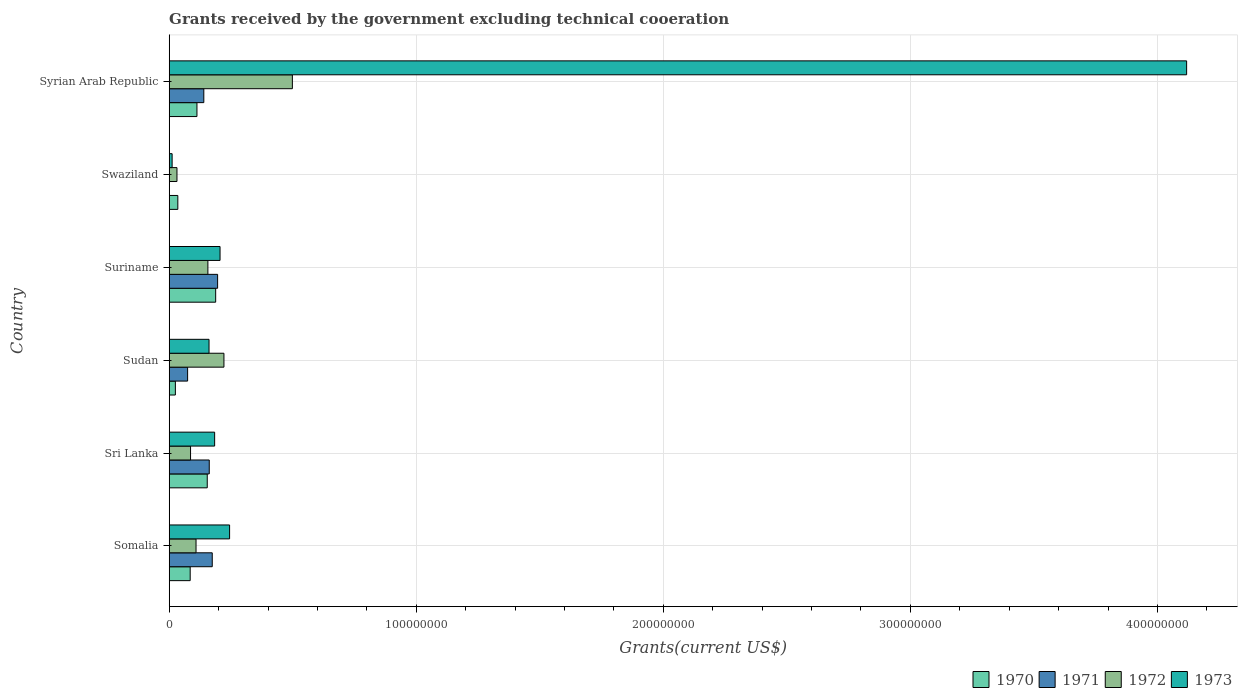How many bars are there on the 1st tick from the top?
Provide a succinct answer. 4. What is the label of the 3rd group of bars from the top?
Your answer should be very brief. Suriname. What is the total grants received by the government in 1970 in Sri Lanka?
Give a very brief answer. 1.54e+07. Across all countries, what is the maximum total grants received by the government in 1973?
Give a very brief answer. 4.12e+08. Across all countries, what is the minimum total grants received by the government in 1973?
Your response must be concise. 1.18e+06. In which country was the total grants received by the government in 1973 maximum?
Your response must be concise. Syrian Arab Republic. What is the total total grants received by the government in 1971 in the graph?
Offer a terse response. 7.47e+07. What is the difference between the total grants received by the government in 1972 in Sri Lanka and that in Sudan?
Your answer should be compact. -1.35e+07. What is the difference between the total grants received by the government in 1973 in Syrian Arab Republic and the total grants received by the government in 1970 in Swaziland?
Make the answer very short. 4.08e+08. What is the average total grants received by the government in 1971 per country?
Offer a terse response. 1.24e+07. What is the difference between the total grants received by the government in 1970 and total grants received by the government in 1971 in Somalia?
Provide a succinct answer. -8.93e+06. What is the ratio of the total grants received by the government in 1970 in Sudan to that in Syrian Arab Republic?
Provide a succinct answer. 0.22. Is the total grants received by the government in 1973 in Suriname less than that in Swaziland?
Offer a very short reply. No. Is the difference between the total grants received by the government in 1970 in Sudan and Suriname greater than the difference between the total grants received by the government in 1971 in Sudan and Suriname?
Your answer should be compact. No. What is the difference between the highest and the second highest total grants received by the government in 1972?
Give a very brief answer. 2.77e+07. What is the difference between the highest and the lowest total grants received by the government in 1970?
Offer a very short reply. 1.63e+07. Does the graph contain grids?
Offer a terse response. Yes. What is the title of the graph?
Provide a short and direct response. Grants received by the government excluding technical cooeration. Does "1987" appear as one of the legend labels in the graph?
Your response must be concise. No. What is the label or title of the X-axis?
Your answer should be very brief. Grants(current US$). What is the Grants(current US$) in 1970 in Somalia?
Keep it short and to the point. 8.49e+06. What is the Grants(current US$) in 1971 in Somalia?
Give a very brief answer. 1.74e+07. What is the Grants(current US$) in 1972 in Somalia?
Ensure brevity in your answer.  1.09e+07. What is the Grants(current US$) in 1973 in Somalia?
Ensure brevity in your answer.  2.44e+07. What is the Grants(current US$) in 1970 in Sri Lanka?
Give a very brief answer. 1.54e+07. What is the Grants(current US$) in 1971 in Sri Lanka?
Your response must be concise. 1.62e+07. What is the Grants(current US$) of 1972 in Sri Lanka?
Your answer should be very brief. 8.64e+06. What is the Grants(current US$) of 1973 in Sri Lanka?
Offer a terse response. 1.84e+07. What is the Grants(current US$) of 1970 in Sudan?
Offer a very short reply. 2.50e+06. What is the Grants(current US$) in 1971 in Sudan?
Your response must be concise. 7.45e+06. What is the Grants(current US$) in 1972 in Sudan?
Provide a succinct answer. 2.22e+07. What is the Grants(current US$) of 1973 in Sudan?
Your answer should be very brief. 1.61e+07. What is the Grants(current US$) in 1970 in Suriname?
Provide a succinct answer. 1.88e+07. What is the Grants(current US$) in 1971 in Suriname?
Your answer should be compact. 1.96e+07. What is the Grants(current US$) of 1972 in Suriname?
Your answer should be very brief. 1.57e+07. What is the Grants(current US$) in 1973 in Suriname?
Provide a short and direct response. 2.06e+07. What is the Grants(current US$) of 1970 in Swaziland?
Offer a very short reply. 3.49e+06. What is the Grants(current US$) of 1971 in Swaziland?
Offer a very short reply. 0. What is the Grants(current US$) of 1972 in Swaziland?
Give a very brief answer. 3.14e+06. What is the Grants(current US$) of 1973 in Swaziland?
Offer a terse response. 1.18e+06. What is the Grants(current US$) of 1970 in Syrian Arab Republic?
Your answer should be very brief. 1.12e+07. What is the Grants(current US$) in 1971 in Syrian Arab Republic?
Provide a short and direct response. 1.40e+07. What is the Grants(current US$) of 1972 in Syrian Arab Republic?
Keep it short and to the point. 4.98e+07. What is the Grants(current US$) of 1973 in Syrian Arab Republic?
Ensure brevity in your answer.  4.12e+08. Across all countries, what is the maximum Grants(current US$) in 1970?
Offer a very short reply. 1.88e+07. Across all countries, what is the maximum Grants(current US$) in 1971?
Offer a very short reply. 1.96e+07. Across all countries, what is the maximum Grants(current US$) of 1972?
Ensure brevity in your answer.  4.98e+07. Across all countries, what is the maximum Grants(current US$) in 1973?
Ensure brevity in your answer.  4.12e+08. Across all countries, what is the minimum Grants(current US$) of 1970?
Provide a short and direct response. 2.50e+06. Across all countries, what is the minimum Grants(current US$) in 1972?
Provide a succinct answer. 3.14e+06. Across all countries, what is the minimum Grants(current US$) in 1973?
Provide a succinct answer. 1.18e+06. What is the total Grants(current US$) of 1970 in the graph?
Give a very brief answer. 5.99e+07. What is the total Grants(current US$) of 1971 in the graph?
Your answer should be compact. 7.47e+07. What is the total Grants(current US$) of 1972 in the graph?
Your answer should be very brief. 1.10e+08. What is the total Grants(current US$) of 1973 in the graph?
Make the answer very short. 4.93e+08. What is the difference between the Grants(current US$) in 1970 in Somalia and that in Sri Lanka?
Keep it short and to the point. -6.91e+06. What is the difference between the Grants(current US$) of 1971 in Somalia and that in Sri Lanka?
Provide a succinct answer. 1.21e+06. What is the difference between the Grants(current US$) in 1972 in Somalia and that in Sri Lanka?
Ensure brevity in your answer.  2.22e+06. What is the difference between the Grants(current US$) in 1973 in Somalia and that in Sri Lanka?
Ensure brevity in your answer.  6.05e+06. What is the difference between the Grants(current US$) of 1970 in Somalia and that in Sudan?
Offer a very short reply. 5.99e+06. What is the difference between the Grants(current US$) of 1971 in Somalia and that in Sudan?
Keep it short and to the point. 9.97e+06. What is the difference between the Grants(current US$) of 1972 in Somalia and that in Sudan?
Give a very brief answer. -1.13e+07. What is the difference between the Grants(current US$) of 1973 in Somalia and that in Sudan?
Offer a terse response. 8.32e+06. What is the difference between the Grants(current US$) in 1970 in Somalia and that in Suriname?
Make the answer very short. -1.03e+07. What is the difference between the Grants(current US$) in 1971 in Somalia and that in Suriname?
Provide a succinct answer. -2.17e+06. What is the difference between the Grants(current US$) of 1972 in Somalia and that in Suriname?
Your response must be concise. -4.80e+06. What is the difference between the Grants(current US$) in 1973 in Somalia and that in Suriname?
Make the answer very short. 3.86e+06. What is the difference between the Grants(current US$) of 1972 in Somalia and that in Swaziland?
Offer a terse response. 7.72e+06. What is the difference between the Grants(current US$) of 1973 in Somalia and that in Swaziland?
Offer a very short reply. 2.33e+07. What is the difference between the Grants(current US$) in 1970 in Somalia and that in Syrian Arab Republic?
Your answer should be compact. -2.74e+06. What is the difference between the Grants(current US$) of 1971 in Somalia and that in Syrian Arab Republic?
Your answer should be very brief. 3.41e+06. What is the difference between the Grants(current US$) in 1972 in Somalia and that in Syrian Arab Republic?
Keep it short and to the point. -3.90e+07. What is the difference between the Grants(current US$) of 1973 in Somalia and that in Syrian Arab Republic?
Provide a succinct answer. -3.87e+08. What is the difference between the Grants(current US$) of 1970 in Sri Lanka and that in Sudan?
Your answer should be very brief. 1.29e+07. What is the difference between the Grants(current US$) of 1971 in Sri Lanka and that in Sudan?
Provide a short and direct response. 8.76e+06. What is the difference between the Grants(current US$) of 1972 in Sri Lanka and that in Sudan?
Your response must be concise. -1.35e+07. What is the difference between the Grants(current US$) in 1973 in Sri Lanka and that in Sudan?
Offer a terse response. 2.27e+06. What is the difference between the Grants(current US$) of 1970 in Sri Lanka and that in Suriname?
Ensure brevity in your answer.  -3.41e+06. What is the difference between the Grants(current US$) in 1971 in Sri Lanka and that in Suriname?
Provide a short and direct response. -3.38e+06. What is the difference between the Grants(current US$) in 1972 in Sri Lanka and that in Suriname?
Your answer should be very brief. -7.02e+06. What is the difference between the Grants(current US$) of 1973 in Sri Lanka and that in Suriname?
Your answer should be very brief. -2.19e+06. What is the difference between the Grants(current US$) in 1970 in Sri Lanka and that in Swaziland?
Offer a terse response. 1.19e+07. What is the difference between the Grants(current US$) of 1972 in Sri Lanka and that in Swaziland?
Ensure brevity in your answer.  5.50e+06. What is the difference between the Grants(current US$) of 1973 in Sri Lanka and that in Swaziland?
Keep it short and to the point. 1.72e+07. What is the difference between the Grants(current US$) in 1970 in Sri Lanka and that in Syrian Arab Republic?
Keep it short and to the point. 4.17e+06. What is the difference between the Grants(current US$) in 1971 in Sri Lanka and that in Syrian Arab Republic?
Give a very brief answer. 2.20e+06. What is the difference between the Grants(current US$) of 1972 in Sri Lanka and that in Syrian Arab Republic?
Ensure brevity in your answer.  -4.12e+07. What is the difference between the Grants(current US$) in 1973 in Sri Lanka and that in Syrian Arab Republic?
Ensure brevity in your answer.  -3.93e+08. What is the difference between the Grants(current US$) in 1970 in Sudan and that in Suriname?
Offer a terse response. -1.63e+07. What is the difference between the Grants(current US$) of 1971 in Sudan and that in Suriname?
Ensure brevity in your answer.  -1.21e+07. What is the difference between the Grants(current US$) of 1972 in Sudan and that in Suriname?
Your answer should be compact. 6.49e+06. What is the difference between the Grants(current US$) of 1973 in Sudan and that in Suriname?
Offer a very short reply. -4.46e+06. What is the difference between the Grants(current US$) of 1970 in Sudan and that in Swaziland?
Keep it short and to the point. -9.90e+05. What is the difference between the Grants(current US$) of 1972 in Sudan and that in Swaziland?
Ensure brevity in your answer.  1.90e+07. What is the difference between the Grants(current US$) in 1973 in Sudan and that in Swaziland?
Give a very brief answer. 1.49e+07. What is the difference between the Grants(current US$) of 1970 in Sudan and that in Syrian Arab Republic?
Provide a succinct answer. -8.73e+06. What is the difference between the Grants(current US$) in 1971 in Sudan and that in Syrian Arab Republic?
Your answer should be compact. -6.56e+06. What is the difference between the Grants(current US$) in 1972 in Sudan and that in Syrian Arab Republic?
Your answer should be compact. -2.77e+07. What is the difference between the Grants(current US$) in 1973 in Sudan and that in Syrian Arab Republic?
Provide a succinct answer. -3.96e+08. What is the difference between the Grants(current US$) of 1970 in Suriname and that in Swaziland?
Keep it short and to the point. 1.53e+07. What is the difference between the Grants(current US$) of 1972 in Suriname and that in Swaziland?
Keep it short and to the point. 1.25e+07. What is the difference between the Grants(current US$) of 1973 in Suriname and that in Swaziland?
Offer a very short reply. 1.94e+07. What is the difference between the Grants(current US$) in 1970 in Suriname and that in Syrian Arab Republic?
Provide a short and direct response. 7.58e+06. What is the difference between the Grants(current US$) of 1971 in Suriname and that in Syrian Arab Republic?
Offer a terse response. 5.58e+06. What is the difference between the Grants(current US$) in 1972 in Suriname and that in Syrian Arab Republic?
Your answer should be compact. -3.42e+07. What is the difference between the Grants(current US$) in 1973 in Suriname and that in Syrian Arab Republic?
Your response must be concise. -3.91e+08. What is the difference between the Grants(current US$) in 1970 in Swaziland and that in Syrian Arab Republic?
Your response must be concise. -7.74e+06. What is the difference between the Grants(current US$) in 1972 in Swaziland and that in Syrian Arab Republic?
Offer a very short reply. -4.67e+07. What is the difference between the Grants(current US$) of 1973 in Swaziland and that in Syrian Arab Republic?
Provide a succinct answer. -4.11e+08. What is the difference between the Grants(current US$) in 1970 in Somalia and the Grants(current US$) in 1971 in Sri Lanka?
Provide a succinct answer. -7.72e+06. What is the difference between the Grants(current US$) in 1970 in Somalia and the Grants(current US$) in 1973 in Sri Lanka?
Make the answer very short. -9.90e+06. What is the difference between the Grants(current US$) in 1971 in Somalia and the Grants(current US$) in 1972 in Sri Lanka?
Your response must be concise. 8.78e+06. What is the difference between the Grants(current US$) in 1971 in Somalia and the Grants(current US$) in 1973 in Sri Lanka?
Your answer should be very brief. -9.70e+05. What is the difference between the Grants(current US$) in 1972 in Somalia and the Grants(current US$) in 1973 in Sri Lanka?
Offer a terse response. -7.53e+06. What is the difference between the Grants(current US$) in 1970 in Somalia and the Grants(current US$) in 1971 in Sudan?
Offer a very short reply. 1.04e+06. What is the difference between the Grants(current US$) of 1970 in Somalia and the Grants(current US$) of 1972 in Sudan?
Your response must be concise. -1.37e+07. What is the difference between the Grants(current US$) in 1970 in Somalia and the Grants(current US$) in 1973 in Sudan?
Keep it short and to the point. -7.63e+06. What is the difference between the Grants(current US$) in 1971 in Somalia and the Grants(current US$) in 1972 in Sudan?
Offer a very short reply. -4.73e+06. What is the difference between the Grants(current US$) of 1971 in Somalia and the Grants(current US$) of 1973 in Sudan?
Offer a very short reply. 1.30e+06. What is the difference between the Grants(current US$) of 1972 in Somalia and the Grants(current US$) of 1973 in Sudan?
Your answer should be compact. -5.26e+06. What is the difference between the Grants(current US$) in 1970 in Somalia and the Grants(current US$) in 1971 in Suriname?
Offer a terse response. -1.11e+07. What is the difference between the Grants(current US$) of 1970 in Somalia and the Grants(current US$) of 1972 in Suriname?
Give a very brief answer. -7.17e+06. What is the difference between the Grants(current US$) in 1970 in Somalia and the Grants(current US$) in 1973 in Suriname?
Offer a terse response. -1.21e+07. What is the difference between the Grants(current US$) of 1971 in Somalia and the Grants(current US$) of 1972 in Suriname?
Make the answer very short. 1.76e+06. What is the difference between the Grants(current US$) of 1971 in Somalia and the Grants(current US$) of 1973 in Suriname?
Make the answer very short. -3.16e+06. What is the difference between the Grants(current US$) of 1972 in Somalia and the Grants(current US$) of 1973 in Suriname?
Your answer should be compact. -9.72e+06. What is the difference between the Grants(current US$) of 1970 in Somalia and the Grants(current US$) of 1972 in Swaziland?
Your answer should be compact. 5.35e+06. What is the difference between the Grants(current US$) of 1970 in Somalia and the Grants(current US$) of 1973 in Swaziland?
Provide a short and direct response. 7.31e+06. What is the difference between the Grants(current US$) in 1971 in Somalia and the Grants(current US$) in 1972 in Swaziland?
Give a very brief answer. 1.43e+07. What is the difference between the Grants(current US$) in 1971 in Somalia and the Grants(current US$) in 1973 in Swaziland?
Give a very brief answer. 1.62e+07. What is the difference between the Grants(current US$) in 1972 in Somalia and the Grants(current US$) in 1973 in Swaziland?
Offer a very short reply. 9.68e+06. What is the difference between the Grants(current US$) in 1970 in Somalia and the Grants(current US$) in 1971 in Syrian Arab Republic?
Make the answer very short. -5.52e+06. What is the difference between the Grants(current US$) in 1970 in Somalia and the Grants(current US$) in 1972 in Syrian Arab Republic?
Your response must be concise. -4.14e+07. What is the difference between the Grants(current US$) in 1970 in Somalia and the Grants(current US$) in 1973 in Syrian Arab Republic?
Provide a succinct answer. -4.03e+08. What is the difference between the Grants(current US$) in 1971 in Somalia and the Grants(current US$) in 1972 in Syrian Arab Republic?
Ensure brevity in your answer.  -3.24e+07. What is the difference between the Grants(current US$) in 1971 in Somalia and the Grants(current US$) in 1973 in Syrian Arab Republic?
Your answer should be compact. -3.94e+08. What is the difference between the Grants(current US$) of 1972 in Somalia and the Grants(current US$) of 1973 in Syrian Arab Republic?
Offer a terse response. -4.01e+08. What is the difference between the Grants(current US$) in 1970 in Sri Lanka and the Grants(current US$) in 1971 in Sudan?
Ensure brevity in your answer.  7.95e+06. What is the difference between the Grants(current US$) of 1970 in Sri Lanka and the Grants(current US$) of 1972 in Sudan?
Your response must be concise. -6.75e+06. What is the difference between the Grants(current US$) of 1970 in Sri Lanka and the Grants(current US$) of 1973 in Sudan?
Offer a terse response. -7.20e+05. What is the difference between the Grants(current US$) of 1971 in Sri Lanka and the Grants(current US$) of 1972 in Sudan?
Give a very brief answer. -5.94e+06. What is the difference between the Grants(current US$) of 1972 in Sri Lanka and the Grants(current US$) of 1973 in Sudan?
Make the answer very short. -7.48e+06. What is the difference between the Grants(current US$) of 1970 in Sri Lanka and the Grants(current US$) of 1971 in Suriname?
Make the answer very short. -4.19e+06. What is the difference between the Grants(current US$) of 1970 in Sri Lanka and the Grants(current US$) of 1973 in Suriname?
Your answer should be compact. -5.18e+06. What is the difference between the Grants(current US$) in 1971 in Sri Lanka and the Grants(current US$) in 1973 in Suriname?
Your answer should be very brief. -4.37e+06. What is the difference between the Grants(current US$) of 1972 in Sri Lanka and the Grants(current US$) of 1973 in Suriname?
Make the answer very short. -1.19e+07. What is the difference between the Grants(current US$) in 1970 in Sri Lanka and the Grants(current US$) in 1972 in Swaziland?
Ensure brevity in your answer.  1.23e+07. What is the difference between the Grants(current US$) in 1970 in Sri Lanka and the Grants(current US$) in 1973 in Swaziland?
Provide a short and direct response. 1.42e+07. What is the difference between the Grants(current US$) in 1971 in Sri Lanka and the Grants(current US$) in 1972 in Swaziland?
Your answer should be compact. 1.31e+07. What is the difference between the Grants(current US$) in 1971 in Sri Lanka and the Grants(current US$) in 1973 in Swaziland?
Your answer should be compact. 1.50e+07. What is the difference between the Grants(current US$) of 1972 in Sri Lanka and the Grants(current US$) of 1973 in Swaziland?
Give a very brief answer. 7.46e+06. What is the difference between the Grants(current US$) of 1970 in Sri Lanka and the Grants(current US$) of 1971 in Syrian Arab Republic?
Provide a succinct answer. 1.39e+06. What is the difference between the Grants(current US$) in 1970 in Sri Lanka and the Grants(current US$) in 1972 in Syrian Arab Republic?
Make the answer very short. -3.44e+07. What is the difference between the Grants(current US$) in 1970 in Sri Lanka and the Grants(current US$) in 1973 in Syrian Arab Republic?
Keep it short and to the point. -3.96e+08. What is the difference between the Grants(current US$) in 1971 in Sri Lanka and the Grants(current US$) in 1972 in Syrian Arab Republic?
Provide a short and direct response. -3.36e+07. What is the difference between the Grants(current US$) of 1971 in Sri Lanka and the Grants(current US$) of 1973 in Syrian Arab Republic?
Offer a very short reply. -3.96e+08. What is the difference between the Grants(current US$) of 1972 in Sri Lanka and the Grants(current US$) of 1973 in Syrian Arab Republic?
Keep it short and to the point. -4.03e+08. What is the difference between the Grants(current US$) of 1970 in Sudan and the Grants(current US$) of 1971 in Suriname?
Give a very brief answer. -1.71e+07. What is the difference between the Grants(current US$) of 1970 in Sudan and the Grants(current US$) of 1972 in Suriname?
Your answer should be very brief. -1.32e+07. What is the difference between the Grants(current US$) in 1970 in Sudan and the Grants(current US$) in 1973 in Suriname?
Offer a very short reply. -1.81e+07. What is the difference between the Grants(current US$) in 1971 in Sudan and the Grants(current US$) in 1972 in Suriname?
Ensure brevity in your answer.  -8.21e+06. What is the difference between the Grants(current US$) in 1971 in Sudan and the Grants(current US$) in 1973 in Suriname?
Provide a short and direct response. -1.31e+07. What is the difference between the Grants(current US$) of 1972 in Sudan and the Grants(current US$) of 1973 in Suriname?
Provide a succinct answer. 1.57e+06. What is the difference between the Grants(current US$) of 1970 in Sudan and the Grants(current US$) of 1972 in Swaziland?
Keep it short and to the point. -6.40e+05. What is the difference between the Grants(current US$) in 1970 in Sudan and the Grants(current US$) in 1973 in Swaziland?
Provide a short and direct response. 1.32e+06. What is the difference between the Grants(current US$) in 1971 in Sudan and the Grants(current US$) in 1972 in Swaziland?
Keep it short and to the point. 4.31e+06. What is the difference between the Grants(current US$) of 1971 in Sudan and the Grants(current US$) of 1973 in Swaziland?
Your answer should be very brief. 6.27e+06. What is the difference between the Grants(current US$) in 1972 in Sudan and the Grants(current US$) in 1973 in Swaziland?
Provide a short and direct response. 2.10e+07. What is the difference between the Grants(current US$) in 1970 in Sudan and the Grants(current US$) in 1971 in Syrian Arab Republic?
Ensure brevity in your answer.  -1.15e+07. What is the difference between the Grants(current US$) of 1970 in Sudan and the Grants(current US$) of 1972 in Syrian Arab Republic?
Provide a succinct answer. -4.74e+07. What is the difference between the Grants(current US$) of 1970 in Sudan and the Grants(current US$) of 1973 in Syrian Arab Republic?
Offer a terse response. -4.09e+08. What is the difference between the Grants(current US$) of 1971 in Sudan and the Grants(current US$) of 1972 in Syrian Arab Republic?
Keep it short and to the point. -4.24e+07. What is the difference between the Grants(current US$) of 1971 in Sudan and the Grants(current US$) of 1973 in Syrian Arab Republic?
Make the answer very short. -4.04e+08. What is the difference between the Grants(current US$) of 1972 in Sudan and the Grants(current US$) of 1973 in Syrian Arab Republic?
Provide a short and direct response. -3.90e+08. What is the difference between the Grants(current US$) of 1970 in Suriname and the Grants(current US$) of 1972 in Swaziland?
Keep it short and to the point. 1.57e+07. What is the difference between the Grants(current US$) of 1970 in Suriname and the Grants(current US$) of 1973 in Swaziland?
Make the answer very short. 1.76e+07. What is the difference between the Grants(current US$) in 1971 in Suriname and the Grants(current US$) in 1972 in Swaziland?
Keep it short and to the point. 1.64e+07. What is the difference between the Grants(current US$) in 1971 in Suriname and the Grants(current US$) in 1973 in Swaziland?
Provide a short and direct response. 1.84e+07. What is the difference between the Grants(current US$) in 1972 in Suriname and the Grants(current US$) in 1973 in Swaziland?
Make the answer very short. 1.45e+07. What is the difference between the Grants(current US$) in 1970 in Suriname and the Grants(current US$) in 1971 in Syrian Arab Republic?
Your answer should be compact. 4.80e+06. What is the difference between the Grants(current US$) in 1970 in Suriname and the Grants(current US$) in 1972 in Syrian Arab Republic?
Offer a terse response. -3.10e+07. What is the difference between the Grants(current US$) of 1970 in Suriname and the Grants(current US$) of 1973 in Syrian Arab Republic?
Your response must be concise. -3.93e+08. What is the difference between the Grants(current US$) in 1971 in Suriname and the Grants(current US$) in 1972 in Syrian Arab Republic?
Ensure brevity in your answer.  -3.03e+07. What is the difference between the Grants(current US$) in 1971 in Suriname and the Grants(current US$) in 1973 in Syrian Arab Republic?
Your answer should be very brief. -3.92e+08. What is the difference between the Grants(current US$) of 1972 in Suriname and the Grants(current US$) of 1973 in Syrian Arab Republic?
Your answer should be very brief. -3.96e+08. What is the difference between the Grants(current US$) of 1970 in Swaziland and the Grants(current US$) of 1971 in Syrian Arab Republic?
Provide a short and direct response. -1.05e+07. What is the difference between the Grants(current US$) of 1970 in Swaziland and the Grants(current US$) of 1972 in Syrian Arab Republic?
Provide a succinct answer. -4.64e+07. What is the difference between the Grants(current US$) in 1970 in Swaziland and the Grants(current US$) in 1973 in Syrian Arab Republic?
Make the answer very short. -4.08e+08. What is the difference between the Grants(current US$) in 1972 in Swaziland and the Grants(current US$) in 1973 in Syrian Arab Republic?
Ensure brevity in your answer.  -4.09e+08. What is the average Grants(current US$) in 1970 per country?
Make the answer very short. 9.99e+06. What is the average Grants(current US$) in 1971 per country?
Give a very brief answer. 1.24e+07. What is the average Grants(current US$) of 1972 per country?
Give a very brief answer. 1.84e+07. What is the average Grants(current US$) in 1973 per country?
Your answer should be compact. 8.21e+07. What is the difference between the Grants(current US$) in 1970 and Grants(current US$) in 1971 in Somalia?
Offer a very short reply. -8.93e+06. What is the difference between the Grants(current US$) of 1970 and Grants(current US$) of 1972 in Somalia?
Ensure brevity in your answer.  -2.37e+06. What is the difference between the Grants(current US$) of 1970 and Grants(current US$) of 1973 in Somalia?
Provide a short and direct response. -1.60e+07. What is the difference between the Grants(current US$) in 1971 and Grants(current US$) in 1972 in Somalia?
Make the answer very short. 6.56e+06. What is the difference between the Grants(current US$) in 1971 and Grants(current US$) in 1973 in Somalia?
Make the answer very short. -7.02e+06. What is the difference between the Grants(current US$) in 1972 and Grants(current US$) in 1973 in Somalia?
Your answer should be very brief. -1.36e+07. What is the difference between the Grants(current US$) in 1970 and Grants(current US$) in 1971 in Sri Lanka?
Your response must be concise. -8.10e+05. What is the difference between the Grants(current US$) in 1970 and Grants(current US$) in 1972 in Sri Lanka?
Ensure brevity in your answer.  6.76e+06. What is the difference between the Grants(current US$) of 1970 and Grants(current US$) of 1973 in Sri Lanka?
Give a very brief answer. -2.99e+06. What is the difference between the Grants(current US$) of 1971 and Grants(current US$) of 1972 in Sri Lanka?
Your answer should be very brief. 7.57e+06. What is the difference between the Grants(current US$) in 1971 and Grants(current US$) in 1973 in Sri Lanka?
Ensure brevity in your answer.  -2.18e+06. What is the difference between the Grants(current US$) in 1972 and Grants(current US$) in 1973 in Sri Lanka?
Provide a succinct answer. -9.75e+06. What is the difference between the Grants(current US$) in 1970 and Grants(current US$) in 1971 in Sudan?
Your answer should be compact. -4.95e+06. What is the difference between the Grants(current US$) in 1970 and Grants(current US$) in 1972 in Sudan?
Provide a short and direct response. -1.96e+07. What is the difference between the Grants(current US$) in 1970 and Grants(current US$) in 1973 in Sudan?
Provide a short and direct response. -1.36e+07. What is the difference between the Grants(current US$) of 1971 and Grants(current US$) of 1972 in Sudan?
Your answer should be compact. -1.47e+07. What is the difference between the Grants(current US$) in 1971 and Grants(current US$) in 1973 in Sudan?
Keep it short and to the point. -8.67e+06. What is the difference between the Grants(current US$) of 1972 and Grants(current US$) of 1973 in Sudan?
Your response must be concise. 6.03e+06. What is the difference between the Grants(current US$) of 1970 and Grants(current US$) of 1971 in Suriname?
Your answer should be compact. -7.80e+05. What is the difference between the Grants(current US$) in 1970 and Grants(current US$) in 1972 in Suriname?
Provide a succinct answer. 3.15e+06. What is the difference between the Grants(current US$) in 1970 and Grants(current US$) in 1973 in Suriname?
Make the answer very short. -1.77e+06. What is the difference between the Grants(current US$) of 1971 and Grants(current US$) of 1972 in Suriname?
Give a very brief answer. 3.93e+06. What is the difference between the Grants(current US$) of 1971 and Grants(current US$) of 1973 in Suriname?
Offer a very short reply. -9.90e+05. What is the difference between the Grants(current US$) of 1972 and Grants(current US$) of 1973 in Suriname?
Your answer should be compact. -4.92e+06. What is the difference between the Grants(current US$) of 1970 and Grants(current US$) of 1973 in Swaziland?
Keep it short and to the point. 2.31e+06. What is the difference between the Grants(current US$) of 1972 and Grants(current US$) of 1973 in Swaziland?
Ensure brevity in your answer.  1.96e+06. What is the difference between the Grants(current US$) of 1970 and Grants(current US$) of 1971 in Syrian Arab Republic?
Keep it short and to the point. -2.78e+06. What is the difference between the Grants(current US$) in 1970 and Grants(current US$) in 1972 in Syrian Arab Republic?
Your answer should be very brief. -3.86e+07. What is the difference between the Grants(current US$) of 1970 and Grants(current US$) of 1973 in Syrian Arab Republic?
Offer a very short reply. -4.01e+08. What is the difference between the Grants(current US$) in 1971 and Grants(current US$) in 1972 in Syrian Arab Republic?
Offer a very short reply. -3.58e+07. What is the difference between the Grants(current US$) in 1971 and Grants(current US$) in 1973 in Syrian Arab Republic?
Keep it short and to the point. -3.98e+08. What is the difference between the Grants(current US$) in 1972 and Grants(current US$) in 1973 in Syrian Arab Republic?
Offer a terse response. -3.62e+08. What is the ratio of the Grants(current US$) in 1970 in Somalia to that in Sri Lanka?
Provide a short and direct response. 0.55. What is the ratio of the Grants(current US$) of 1971 in Somalia to that in Sri Lanka?
Offer a very short reply. 1.07. What is the ratio of the Grants(current US$) of 1972 in Somalia to that in Sri Lanka?
Offer a terse response. 1.26. What is the ratio of the Grants(current US$) of 1973 in Somalia to that in Sri Lanka?
Provide a short and direct response. 1.33. What is the ratio of the Grants(current US$) in 1970 in Somalia to that in Sudan?
Provide a short and direct response. 3.4. What is the ratio of the Grants(current US$) in 1971 in Somalia to that in Sudan?
Ensure brevity in your answer.  2.34. What is the ratio of the Grants(current US$) in 1972 in Somalia to that in Sudan?
Make the answer very short. 0.49. What is the ratio of the Grants(current US$) in 1973 in Somalia to that in Sudan?
Make the answer very short. 1.52. What is the ratio of the Grants(current US$) in 1970 in Somalia to that in Suriname?
Offer a terse response. 0.45. What is the ratio of the Grants(current US$) of 1971 in Somalia to that in Suriname?
Offer a very short reply. 0.89. What is the ratio of the Grants(current US$) of 1972 in Somalia to that in Suriname?
Give a very brief answer. 0.69. What is the ratio of the Grants(current US$) of 1973 in Somalia to that in Suriname?
Offer a terse response. 1.19. What is the ratio of the Grants(current US$) in 1970 in Somalia to that in Swaziland?
Provide a succinct answer. 2.43. What is the ratio of the Grants(current US$) of 1972 in Somalia to that in Swaziland?
Keep it short and to the point. 3.46. What is the ratio of the Grants(current US$) of 1973 in Somalia to that in Swaziland?
Offer a very short reply. 20.71. What is the ratio of the Grants(current US$) in 1970 in Somalia to that in Syrian Arab Republic?
Make the answer very short. 0.76. What is the ratio of the Grants(current US$) of 1971 in Somalia to that in Syrian Arab Republic?
Keep it short and to the point. 1.24. What is the ratio of the Grants(current US$) of 1972 in Somalia to that in Syrian Arab Republic?
Your answer should be compact. 0.22. What is the ratio of the Grants(current US$) of 1973 in Somalia to that in Syrian Arab Republic?
Ensure brevity in your answer.  0.06. What is the ratio of the Grants(current US$) in 1970 in Sri Lanka to that in Sudan?
Your response must be concise. 6.16. What is the ratio of the Grants(current US$) in 1971 in Sri Lanka to that in Sudan?
Give a very brief answer. 2.18. What is the ratio of the Grants(current US$) in 1972 in Sri Lanka to that in Sudan?
Your answer should be compact. 0.39. What is the ratio of the Grants(current US$) in 1973 in Sri Lanka to that in Sudan?
Ensure brevity in your answer.  1.14. What is the ratio of the Grants(current US$) of 1970 in Sri Lanka to that in Suriname?
Your answer should be compact. 0.82. What is the ratio of the Grants(current US$) in 1971 in Sri Lanka to that in Suriname?
Ensure brevity in your answer.  0.83. What is the ratio of the Grants(current US$) in 1972 in Sri Lanka to that in Suriname?
Ensure brevity in your answer.  0.55. What is the ratio of the Grants(current US$) of 1973 in Sri Lanka to that in Suriname?
Your answer should be very brief. 0.89. What is the ratio of the Grants(current US$) of 1970 in Sri Lanka to that in Swaziland?
Offer a terse response. 4.41. What is the ratio of the Grants(current US$) of 1972 in Sri Lanka to that in Swaziland?
Your answer should be very brief. 2.75. What is the ratio of the Grants(current US$) in 1973 in Sri Lanka to that in Swaziland?
Your answer should be compact. 15.58. What is the ratio of the Grants(current US$) of 1970 in Sri Lanka to that in Syrian Arab Republic?
Offer a terse response. 1.37. What is the ratio of the Grants(current US$) of 1971 in Sri Lanka to that in Syrian Arab Republic?
Offer a very short reply. 1.16. What is the ratio of the Grants(current US$) in 1972 in Sri Lanka to that in Syrian Arab Republic?
Ensure brevity in your answer.  0.17. What is the ratio of the Grants(current US$) of 1973 in Sri Lanka to that in Syrian Arab Republic?
Offer a very short reply. 0.04. What is the ratio of the Grants(current US$) in 1970 in Sudan to that in Suriname?
Your answer should be very brief. 0.13. What is the ratio of the Grants(current US$) in 1971 in Sudan to that in Suriname?
Keep it short and to the point. 0.38. What is the ratio of the Grants(current US$) in 1972 in Sudan to that in Suriname?
Offer a terse response. 1.41. What is the ratio of the Grants(current US$) of 1973 in Sudan to that in Suriname?
Your answer should be compact. 0.78. What is the ratio of the Grants(current US$) of 1970 in Sudan to that in Swaziland?
Offer a terse response. 0.72. What is the ratio of the Grants(current US$) of 1972 in Sudan to that in Swaziland?
Provide a succinct answer. 7.05. What is the ratio of the Grants(current US$) of 1973 in Sudan to that in Swaziland?
Offer a very short reply. 13.66. What is the ratio of the Grants(current US$) in 1970 in Sudan to that in Syrian Arab Republic?
Your response must be concise. 0.22. What is the ratio of the Grants(current US$) of 1971 in Sudan to that in Syrian Arab Republic?
Ensure brevity in your answer.  0.53. What is the ratio of the Grants(current US$) of 1972 in Sudan to that in Syrian Arab Republic?
Your answer should be compact. 0.44. What is the ratio of the Grants(current US$) of 1973 in Sudan to that in Syrian Arab Republic?
Make the answer very short. 0.04. What is the ratio of the Grants(current US$) in 1970 in Suriname to that in Swaziland?
Offer a very short reply. 5.39. What is the ratio of the Grants(current US$) of 1972 in Suriname to that in Swaziland?
Offer a terse response. 4.99. What is the ratio of the Grants(current US$) in 1973 in Suriname to that in Swaziland?
Your response must be concise. 17.44. What is the ratio of the Grants(current US$) in 1970 in Suriname to that in Syrian Arab Republic?
Make the answer very short. 1.68. What is the ratio of the Grants(current US$) in 1971 in Suriname to that in Syrian Arab Republic?
Offer a very short reply. 1.4. What is the ratio of the Grants(current US$) in 1972 in Suriname to that in Syrian Arab Republic?
Make the answer very short. 0.31. What is the ratio of the Grants(current US$) in 1973 in Suriname to that in Syrian Arab Republic?
Your response must be concise. 0.05. What is the ratio of the Grants(current US$) of 1970 in Swaziland to that in Syrian Arab Republic?
Provide a short and direct response. 0.31. What is the ratio of the Grants(current US$) in 1972 in Swaziland to that in Syrian Arab Republic?
Provide a short and direct response. 0.06. What is the ratio of the Grants(current US$) of 1973 in Swaziland to that in Syrian Arab Republic?
Make the answer very short. 0. What is the difference between the highest and the second highest Grants(current US$) in 1970?
Ensure brevity in your answer.  3.41e+06. What is the difference between the highest and the second highest Grants(current US$) in 1971?
Offer a terse response. 2.17e+06. What is the difference between the highest and the second highest Grants(current US$) of 1972?
Your response must be concise. 2.77e+07. What is the difference between the highest and the second highest Grants(current US$) in 1973?
Ensure brevity in your answer.  3.87e+08. What is the difference between the highest and the lowest Grants(current US$) of 1970?
Offer a very short reply. 1.63e+07. What is the difference between the highest and the lowest Grants(current US$) in 1971?
Offer a very short reply. 1.96e+07. What is the difference between the highest and the lowest Grants(current US$) in 1972?
Offer a very short reply. 4.67e+07. What is the difference between the highest and the lowest Grants(current US$) in 1973?
Your answer should be compact. 4.11e+08. 